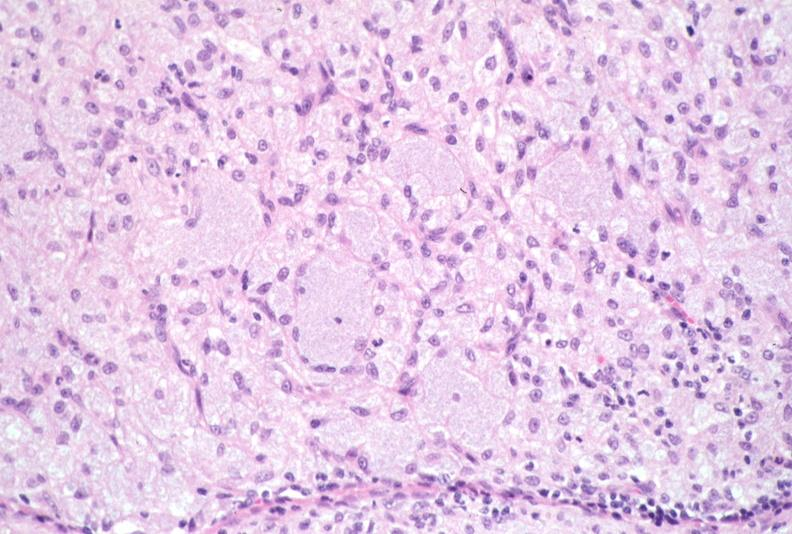what does this image show?
Answer the question using a single word or phrase. Lymph node 